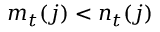Convert formula to latex. <formula><loc_0><loc_0><loc_500><loc_500>m _ { t } ( j ) < n _ { t } ( j )</formula> 